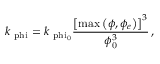<formula> <loc_0><loc_0><loc_500><loc_500>k _ { \ p h i } = k _ { \ p h i _ { \mathrm { 0 } } } \frac { \left [ \max \left ( \phi , \phi _ { e } \right ) \right ] ^ { 3 } } { \phi _ { 0 } ^ { 3 } } \, ,</formula> 